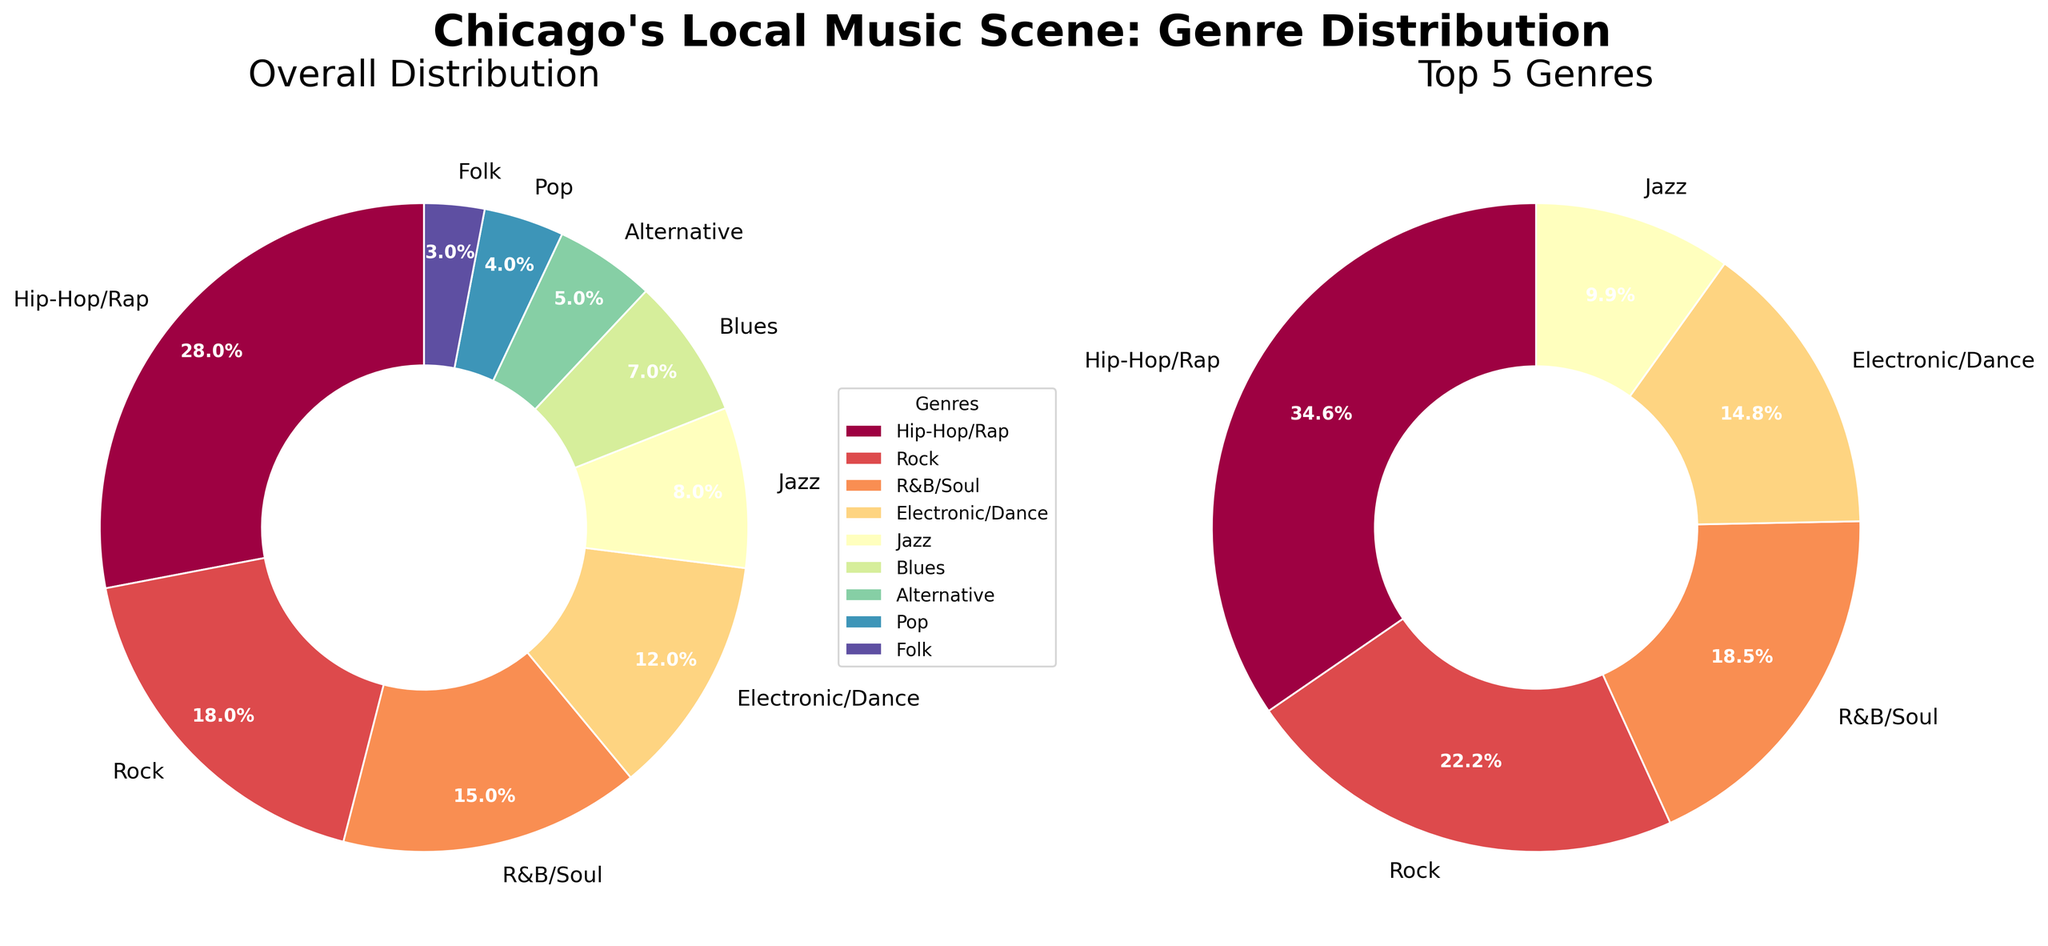What is the most represented genre in Chicago's local music scene? Looking at the pie chart titled "Overall Distribution," the largest wedge represents Hip-Hop/Rap with 28%.
Answer: Hip-Hop/Rap Which genre is less prevalent, Blues or Jazz? By comparing the sections labeled Blues and Jazz in the "Overall Distribution" pie chart, Jazz has 8% whereas Blues has 7%.
Answer: Blues What percentage of Chicago’s local music scene is composed of genres outside the top 5? Summing the percentages of the top 5 genres: Hip-Hop/Rap (28%), Rock (18%), R&B/Soul (15%), Electronic/Dance (12%), and Jazz (8%) gives us 81%. Therefore, 100% - 81% = 19% represents genres outside the top 5.
Answer: 19% How does the distribution of the top 5 genres compare proportionally in the "Top 5 Genres" donut chart? In the "Top 5 Genres" donut chart, Hip-Hop/Rap has the largest proportion, followed by Rock, R&B/Soul, Electronic/Dance, and Jazz in descending order.
Answer: Hip-Hop/Rap > Rock > R&B/Soul > Electronic/Dance > Jazz Which genre has a smaller share in the top 5 genres, Alternative or Pop? Alternative and Pop are not included in the "Top 5 Genres" donut chart, highlighting that their percentages are smaller than Jazz, which has the smallest share among the top 5.
Answer: Both If the category "Hip-Hop/Rap" grew by 5%, how would that affect the overall distribution? Currently, Hip-Hop/Rap is 28%. If it increased by 5%, it would become 28% + 5% = 33%. The new distribution would have to adjust, decrementing the remaining genres' share to sum to 100%.
Answer: Hip-Hop/Rap would be 33% Which two genres combined constitute more than half of the total genre distribution? Summing the top two genres from the "Overall Distribution" chart: Hip-Hop/Rap (28%) and Rock (18%) gives 46%. Adding the third genre R&B/Soul (15%) totals 61%, surpassing half. So, Hip-Hop/Rap and Rock together do not exceed half, but adding R&B/Soul does.
Answer: Hip-Hop/Rap and Rock with R&B/Soul Is the percentage of the genre Folk higher or lower than 5%? The "Overall Distribution" pie chart shows that Folk is represented by a 3% slice.
Answer: Lower How many genres individually account for less than 10% of the distribution? From the "Overall Distribution" chart we see R&B/Soul (15%), Electronic/Dance (12%), Jazz (8%), Blues (7%), Alternative (5%), Pop (4%), and Folk (3%). Counting those below 10% gives us Jazz, Blues, Alternative, Pop, and Folk - so 5 genres.
Answer: Five genres Without looking at the pie charts, how much of the distribution is occupied by genres Rock and Jazz combined? By summing the percentages of Rock (18%) and Jazz (8%) from the "Overall Distribution" chart: 18% + 8% = 26%.
Answer: 26% 